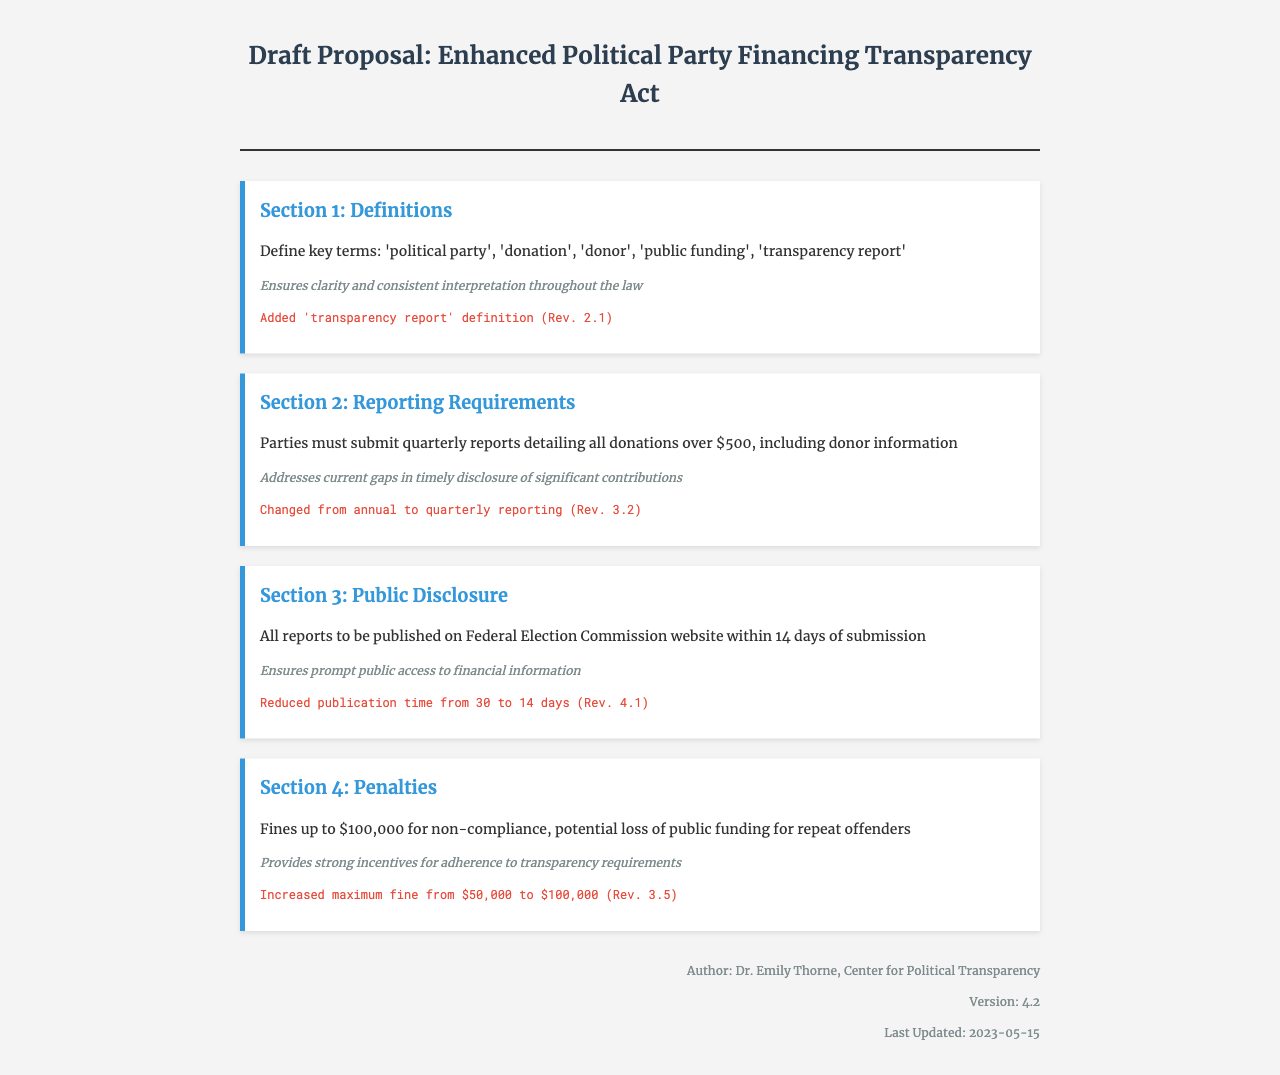What is the title of the proposal? The title of the proposal is presented at the top of the document.
Answer: Enhanced Political Party Financing Transparency Act Who is the author of the document? The author's name is mentioned in the metadata section of the document.
Answer: Dr. Emily Thorne What is the maximum fine for non-compliance? The penalty section specifies the maximum fine stated in the document.
Answer: $100,000 How often must parties submit reports? The reporting requirements section clarifies the frequency of report submissions.
Answer: Quarterly What is the deadline for public disclosure after submission? The public disclosure section states the timeline for publishing reports.
Answer: 14 days What revision version is the document currently at? The version is noted in the metadata section at the end of the document.
Answer: 4.2 What significant change was made in Revision 3.2? Revision history highlights changes made to the reporting frequency.
Answer: Changed from annual to quarterly reporting What is included in the definition section? The definition section outlines key terms relevant to the document.
Answer: 'political party', 'donation', 'donor', 'public funding', 'transparency report' 